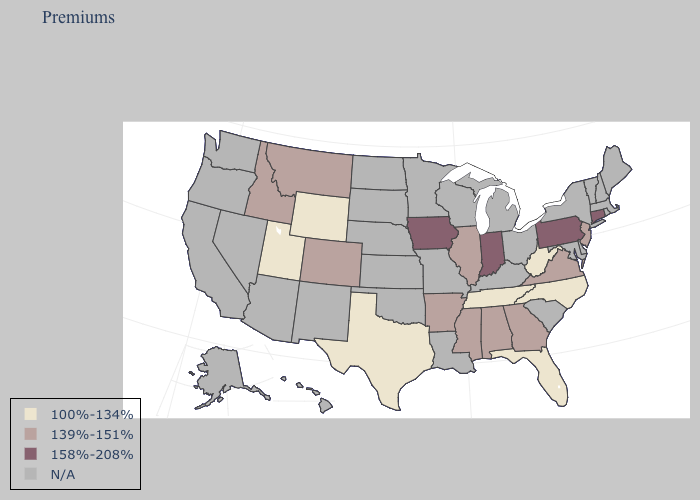What is the highest value in the South ?
Be succinct. 139%-151%. Name the states that have a value in the range 139%-151%?
Answer briefly. Alabama, Arkansas, Colorado, Georgia, Idaho, Illinois, Mississippi, Montana, New Jersey, Virginia. What is the value of Colorado?
Concise answer only. 139%-151%. What is the lowest value in the West?
Concise answer only. 100%-134%. What is the lowest value in states that border Washington?
Give a very brief answer. 139%-151%. Which states have the lowest value in the Northeast?
Write a very short answer. New Jersey. Is the legend a continuous bar?
Concise answer only. No. What is the lowest value in the USA?
Give a very brief answer. 100%-134%. Does the map have missing data?
Write a very short answer. Yes. Name the states that have a value in the range 158%-208%?
Answer briefly. Connecticut, Indiana, Iowa, Pennsylvania. Name the states that have a value in the range N/A?
Answer briefly. Alaska, Arizona, California, Delaware, Hawaii, Kansas, Kentucky, Louisiana, Maine, Maryland, Massachusetts, Michigan, Minnesota, Missouri, Nebraska, Nevada, New Hampshire, New Mexico, New York, North Dakota, Ohio, Oklahoma, Oregon, Rhode Island, South Carolina, South Dakota, Vermont, Washington, Wisconsin. What is the lowest value in the USA?
Answer briefly. 100%-134%. Which states have the lowest value in the West?
Quick response, please. Utah, Wyoming. Does the first symbol in the legend represent the smallest category?
Quick response, please. Yes. Which states hav the highest value in the West?
Quick response, please. Colorado, Idaho, Montana. 